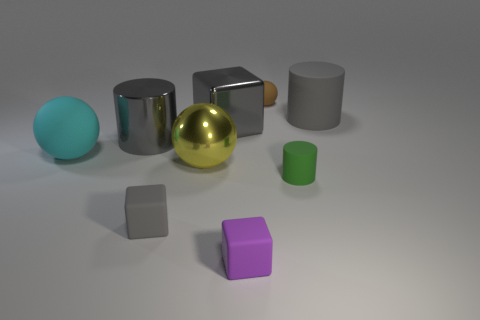How would you describe the arrangement of the objects in the image? The objects are arranged in a staggered fashion from left to right without adhering to any strict pattern. The varying shapes and sizes contribute to an aesthetically pleasing composition, likely intended to showcase the differences in geometry and material qualities. 